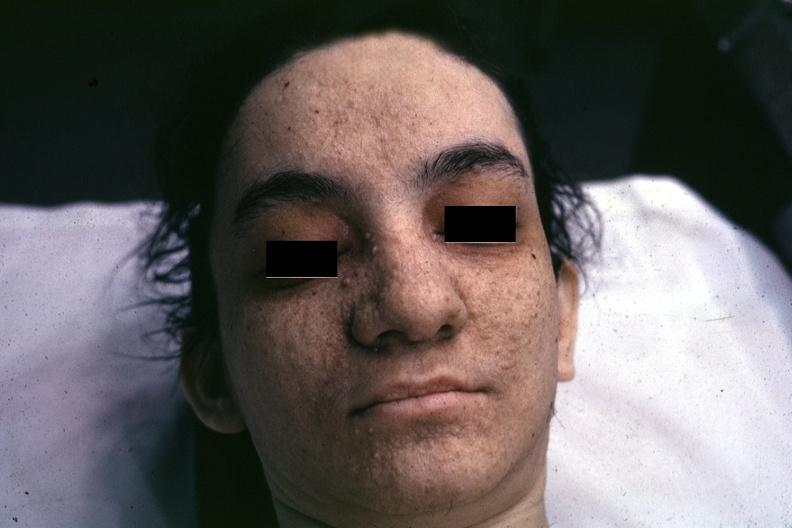what is present?
Answer the question using a single word or phrase. Adenoma sebaceum 